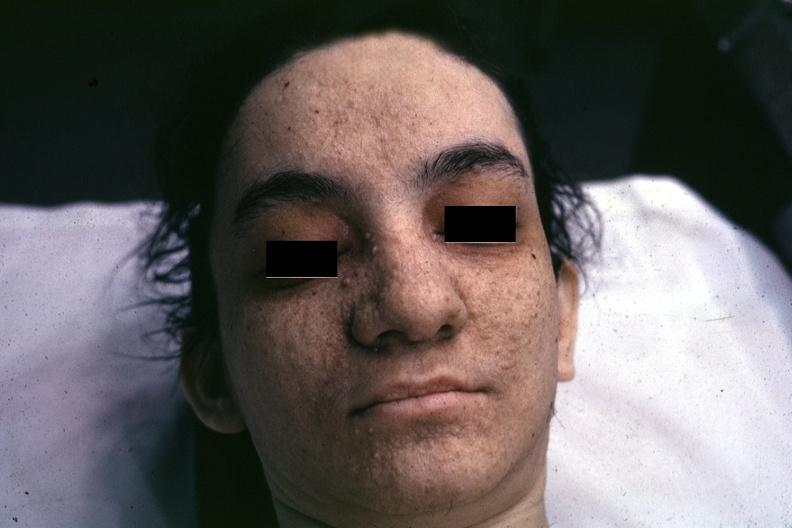what is present?
Answer the question using a single word or phrase. Adenoma sebaceum 